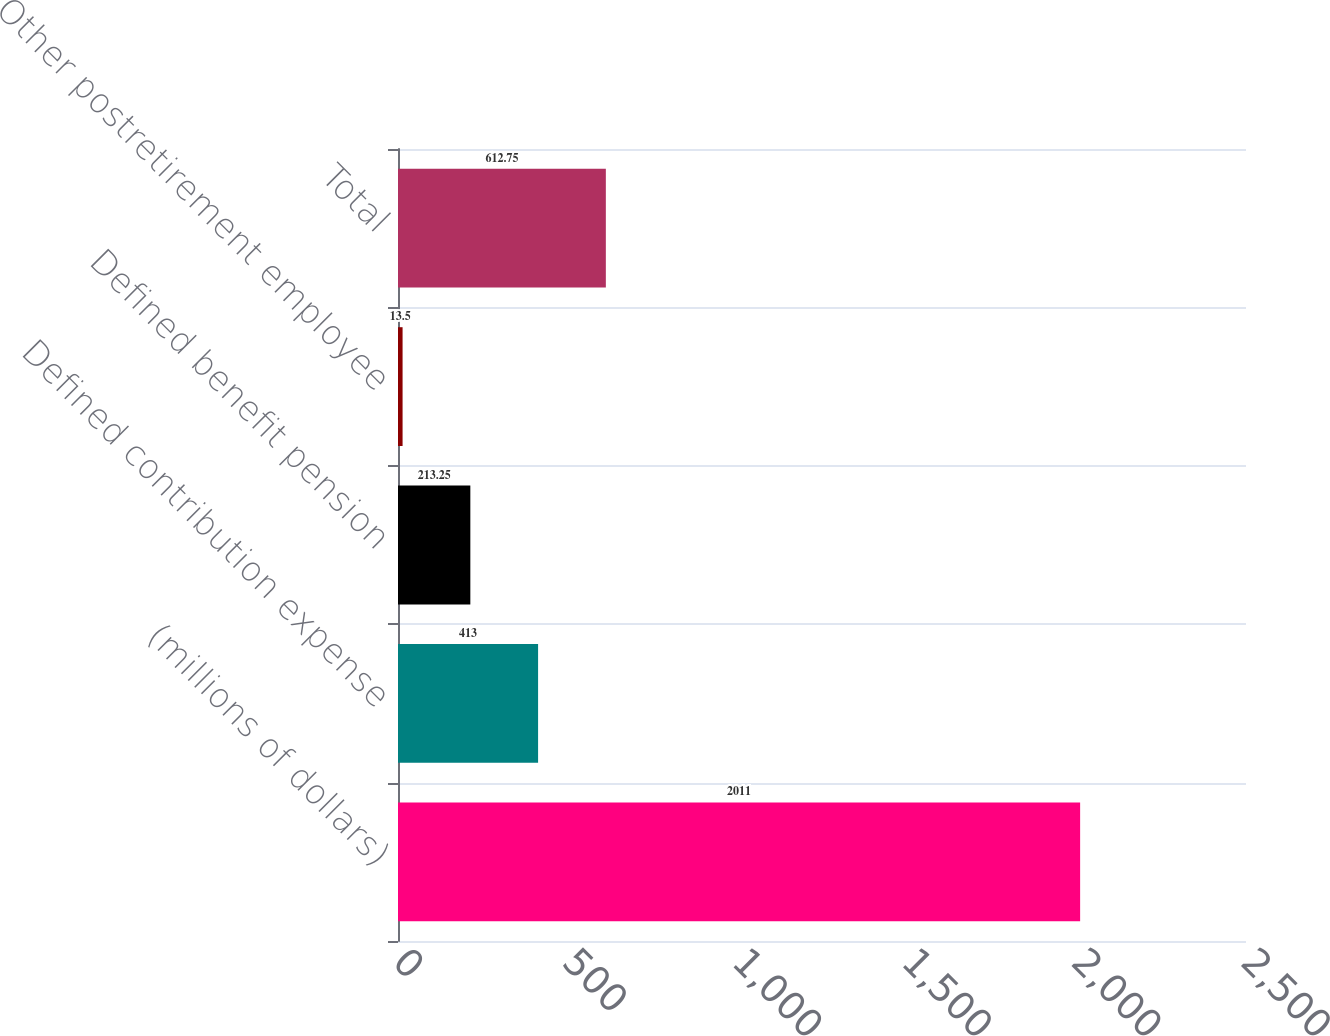Convert chart. <chart><loc_0><loc_0><loc_500><loc_500><bar_chart><fcel>(millions of dollars)<fcel>Defined contribution expense<fcel>Defined benefit pension<fcel>Other postretirement employee<fcel>Total<nl><fcel>2011<fcel>413<fcel>213.25<fcel>13.5<fcel>612.75<nl></chart> 